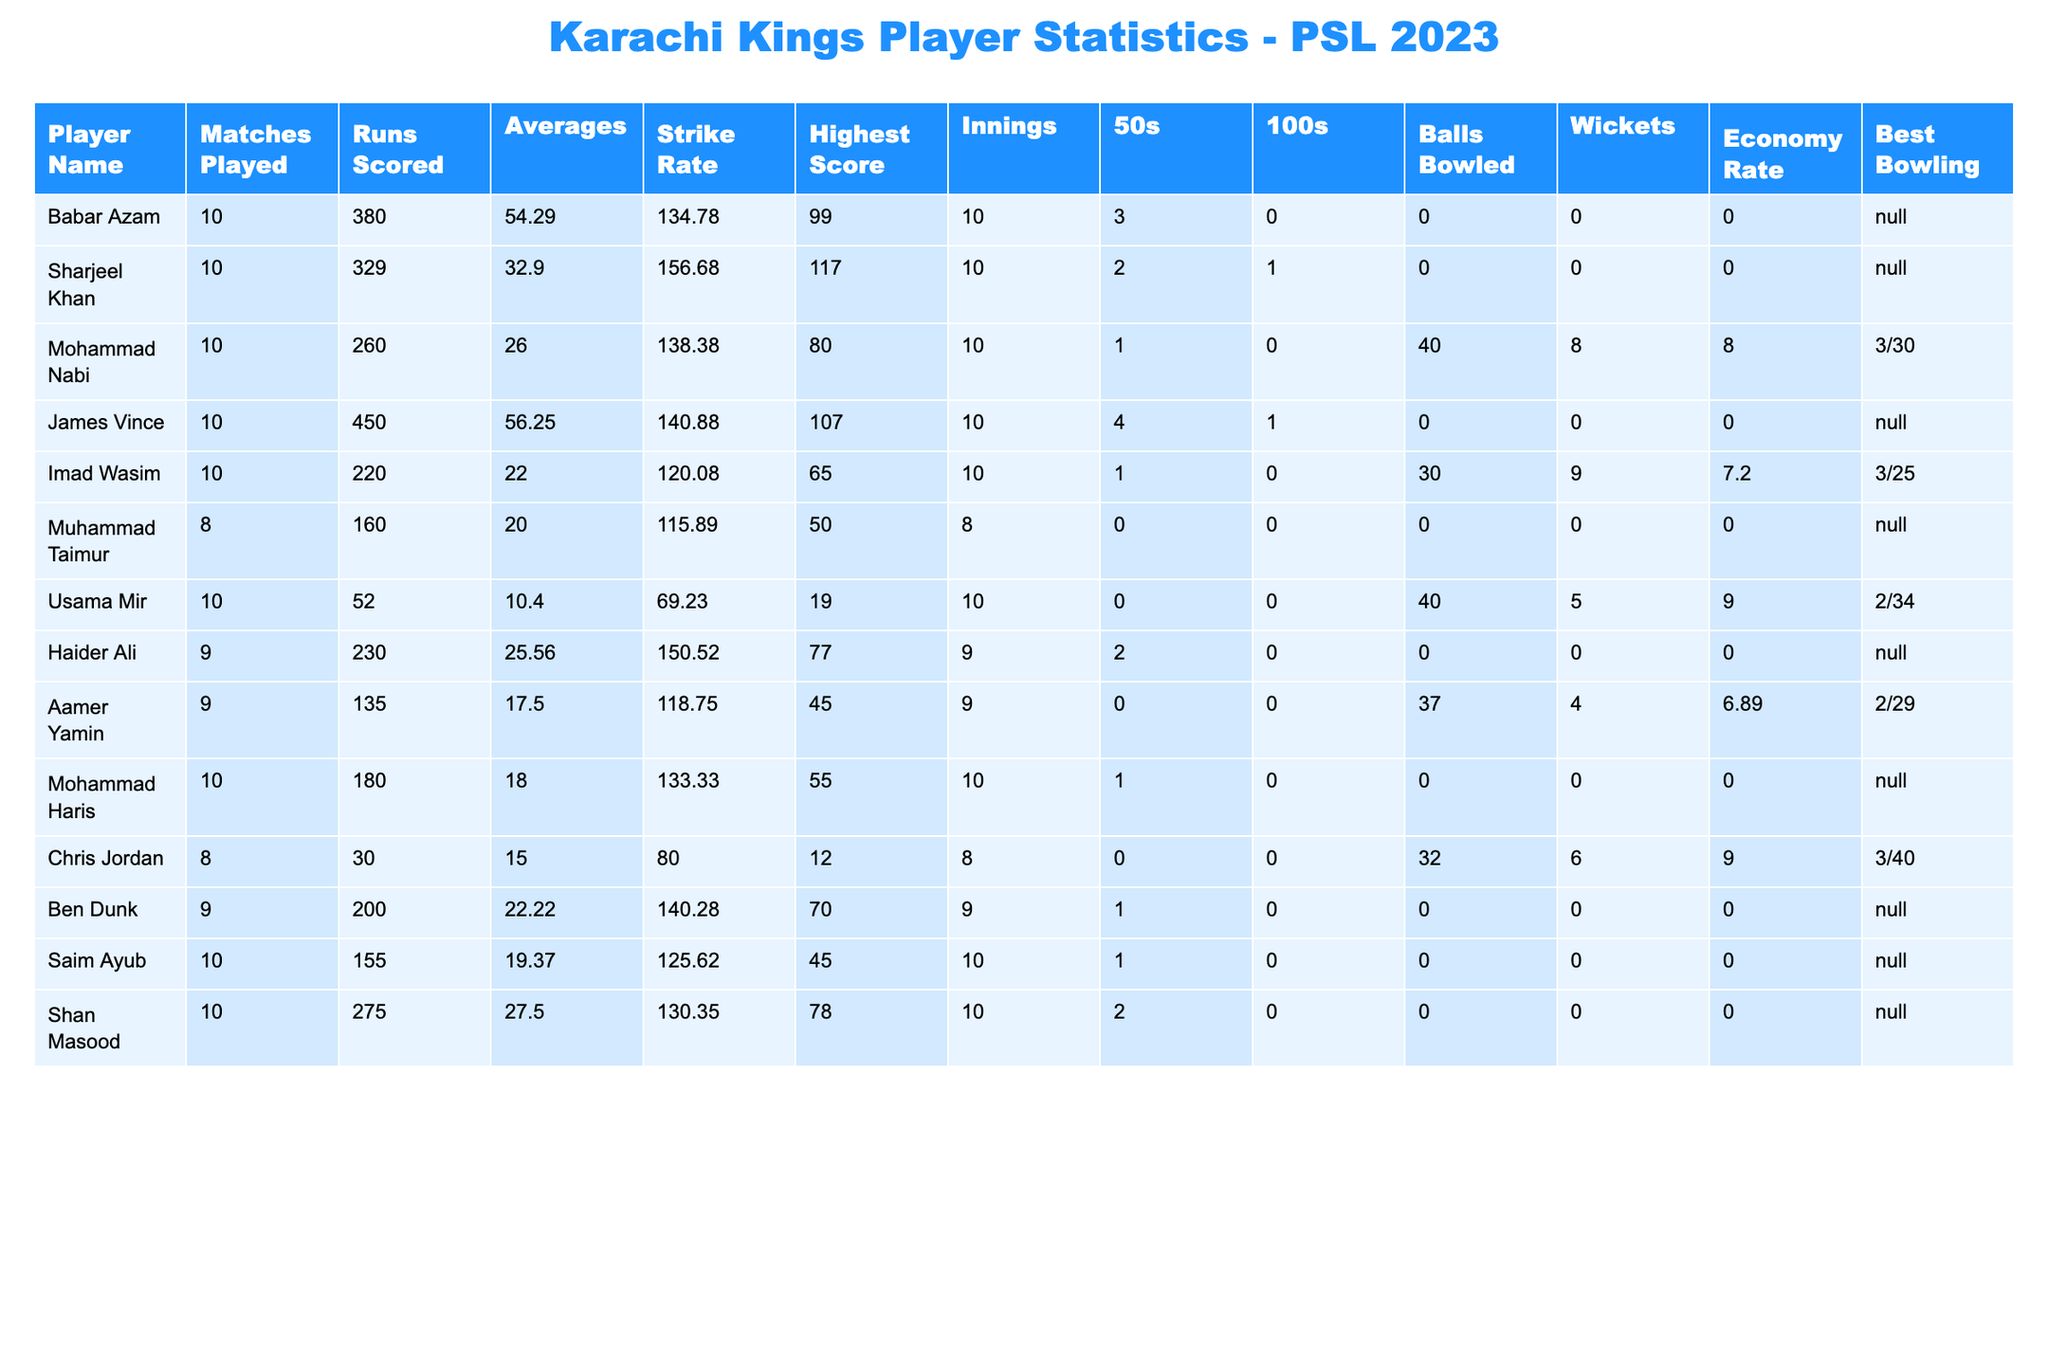What's the highest score by any player? By examining the "Highest Score" column, the maximum value is 117, achieved by Sharjeel Khan.
Answer: 117 Who scored the most runs for Karachi Kings? The "Runs Scored" column shows that James Vince scored the most runs with a total of 450.
Answer: 450 What is the average number of runs scored by Babar Azam? Babar Azam has scored 380 runs over 10 matches, leading to an average of 54.29 as indicated in the "Averages" column.
Answer: 54.29 How many players scored more than 200 runs? By reviewing the "Runs Scored" column, four players—James Vince, Babar Azam, Sharjeel Khan, and San Masood—scored more than 200 runs.
Answer: 4 Is it true that all players played at least 8 matches? Based on the "Matches Played" column, only Muhammad Taimur played 8 matches, while others played 9 or 10, confirming the statement is true.
Answer: True What is the economy rate of the bowler with the best bowling figures? The best bowling figures of 3/30 are recorded by Mohammad Nabi with an economy rate of 8.00, as noted in the respective columns.
Answer: 8.00 How does the average batting performance of James Vince compare with Babar Azam? James Vince has an average of 56.25 while Babar Azam has 54.29. Thus, James Vince has a slightly better average than Babar Azam.
Answer: James Vince has a better average What is the total number of 50s scored by the players? Summing up the "50s" column gives a total of 12 (3 for Babar Azam, 2 for Sharjeel Khan, 1 for Mohammad Nabi, etc.).
Answer: 12 Which player had the highest strike rate? By examining the "Strike Rate" column, Sharjeel Khan holds the highest strike rate at 156.68.
Answer: 156.68 What is the difference in wickets taken between Mohammad Nabi and Imad Wasim? Mohammad Nabi took 8 wickets while Imad Wasim took 9; thus, the difference is 1 wicket.
Answer: 1 